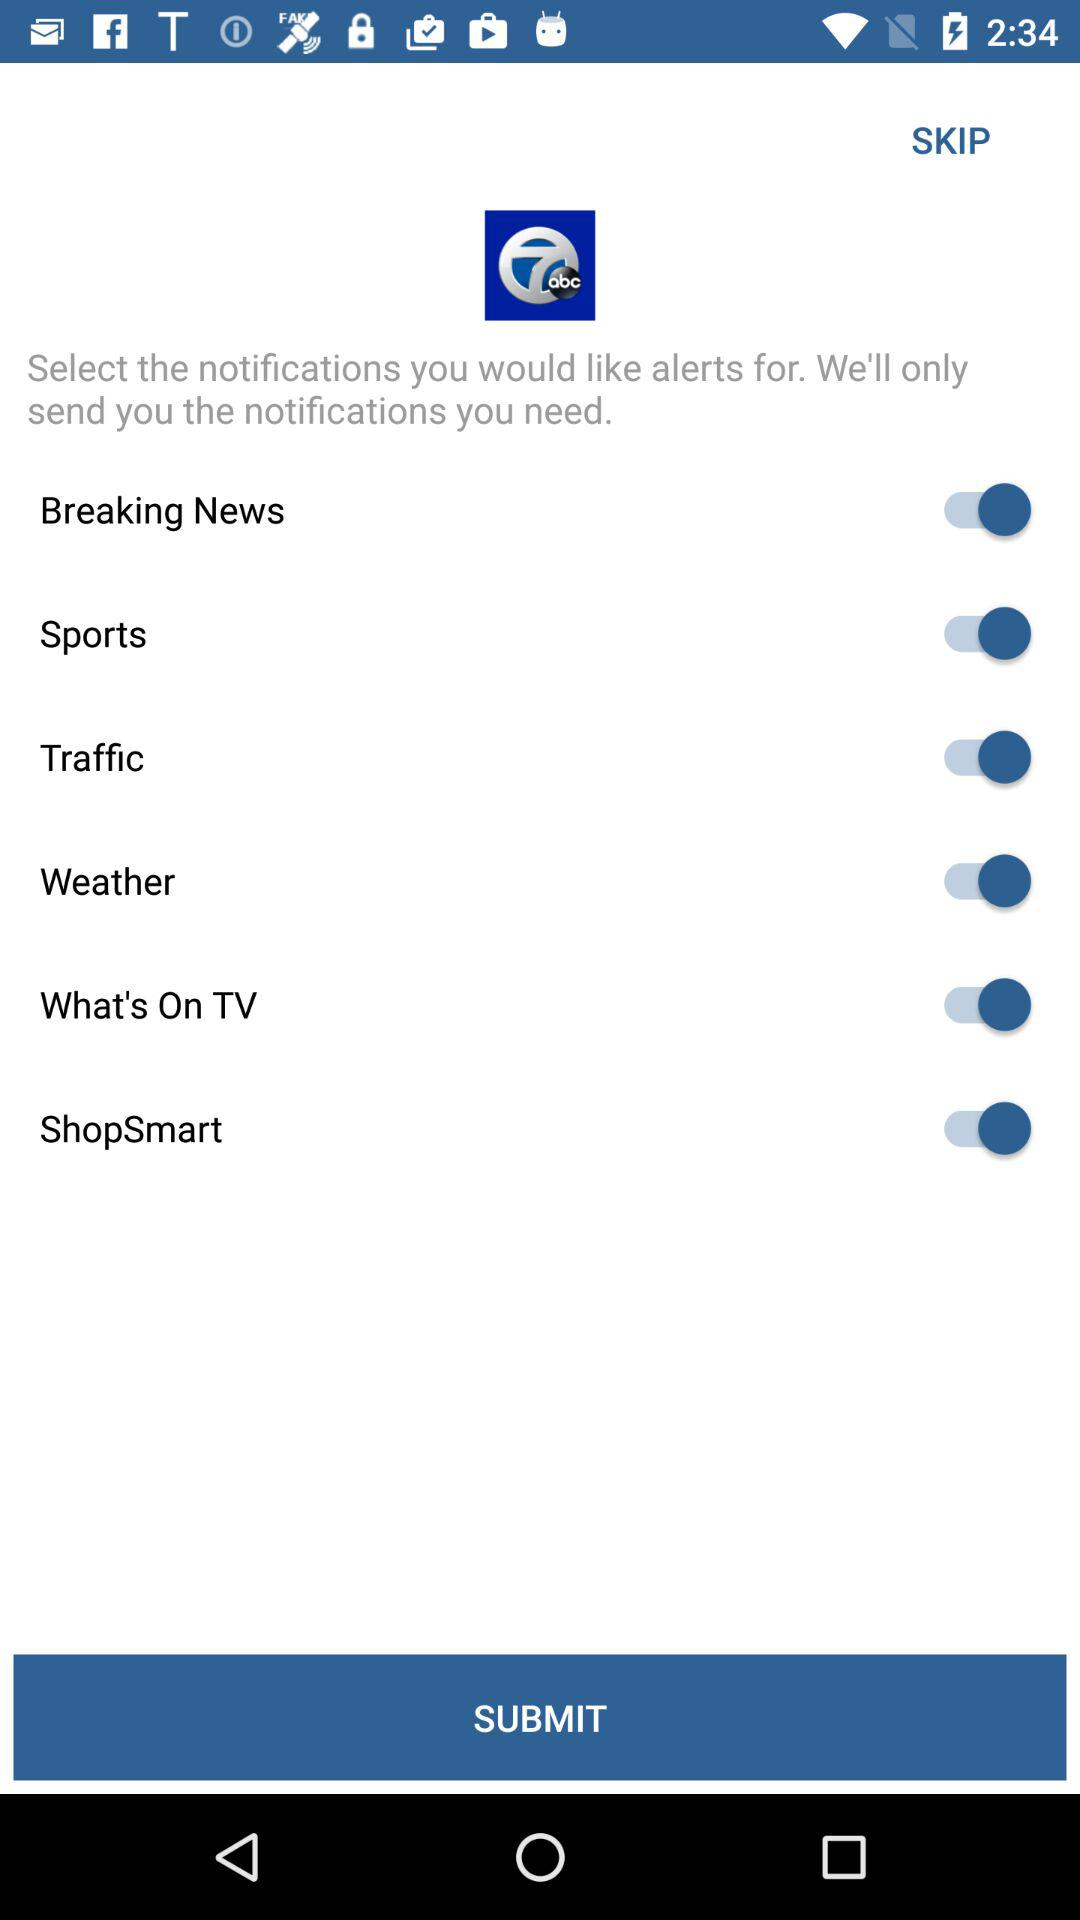What is the status of "Sports"? The status is on. 